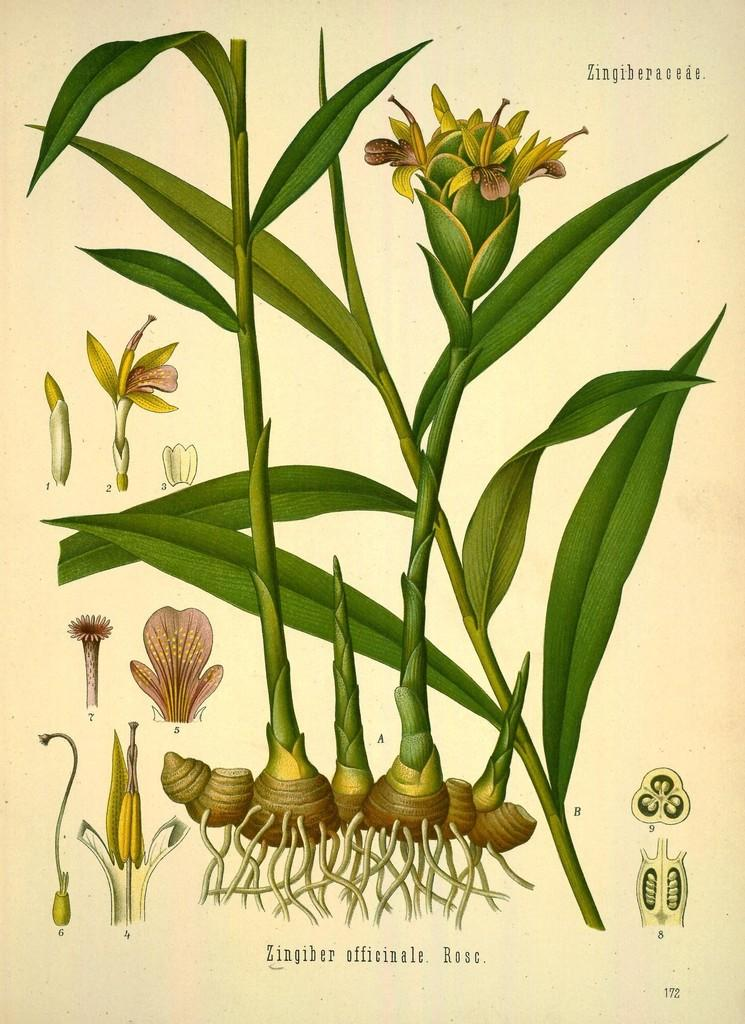What type of image is being described? The image is edited and graphical. What can be seen in the image besides the editing and graphics? There is a plant in the image. Is there any text present in the image? Yes, there is text written on the image. How many houses are visible in the image? There are no houses visible in the image; it features a plant and edited graphics. What type of loaf is being used to support the elbow in the image? There is no loaf or elbow present in the image. 